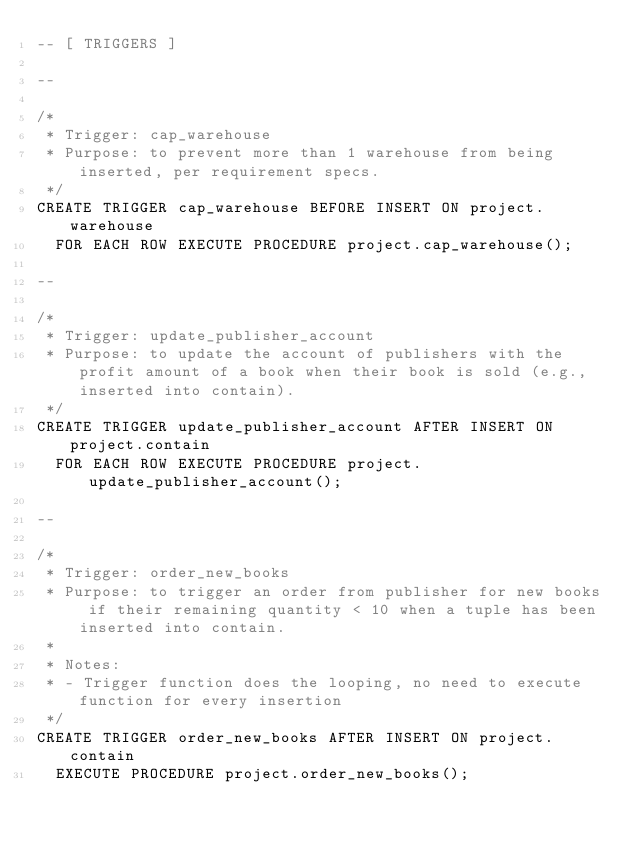Convert code to text. <code><loc_0><loc_0><loc_500><loc_500><_SQL_>-- [ TRIGGERS ]

--

/*
 * Trigger: cap_warehouse
 * Purpose: to prevent more than 1 warehouse from being inserted, per requirement specs.
 */
CREATE TRIGGER cap_warehouse BEFORE INSERT ON project.warehouse
	FOR EACH ROW EXECUTE PROCEDURE project.cap_warehouse();

--

/*
 * Trigger: update_publisher_account
 * Purpose: to update the account of publishers with the profit amount of a book when their book is sold (e.g., inserted into contain).
 */
CREATE TRIGGER update_publisher_account AFTER INSERT ON project.contain
	FOR EACH ROW EXECUTE PROCEDURE project.update_publisher_account();

--

/*
 * Trigger: order_new_books
 * Purpose: to trigger an order from publisher for new books if their remaining quantity < 10 when a tuple has been inserted into contain.
 *
 * Notes:
 * - Trigger function does the looping, no need to execute function for every insertion
 */
CREATE TRIGGER order_new_books AFTER INSERT ON project.contain
	EXECUTE PROCEDURE project.order_new_books();</code> 